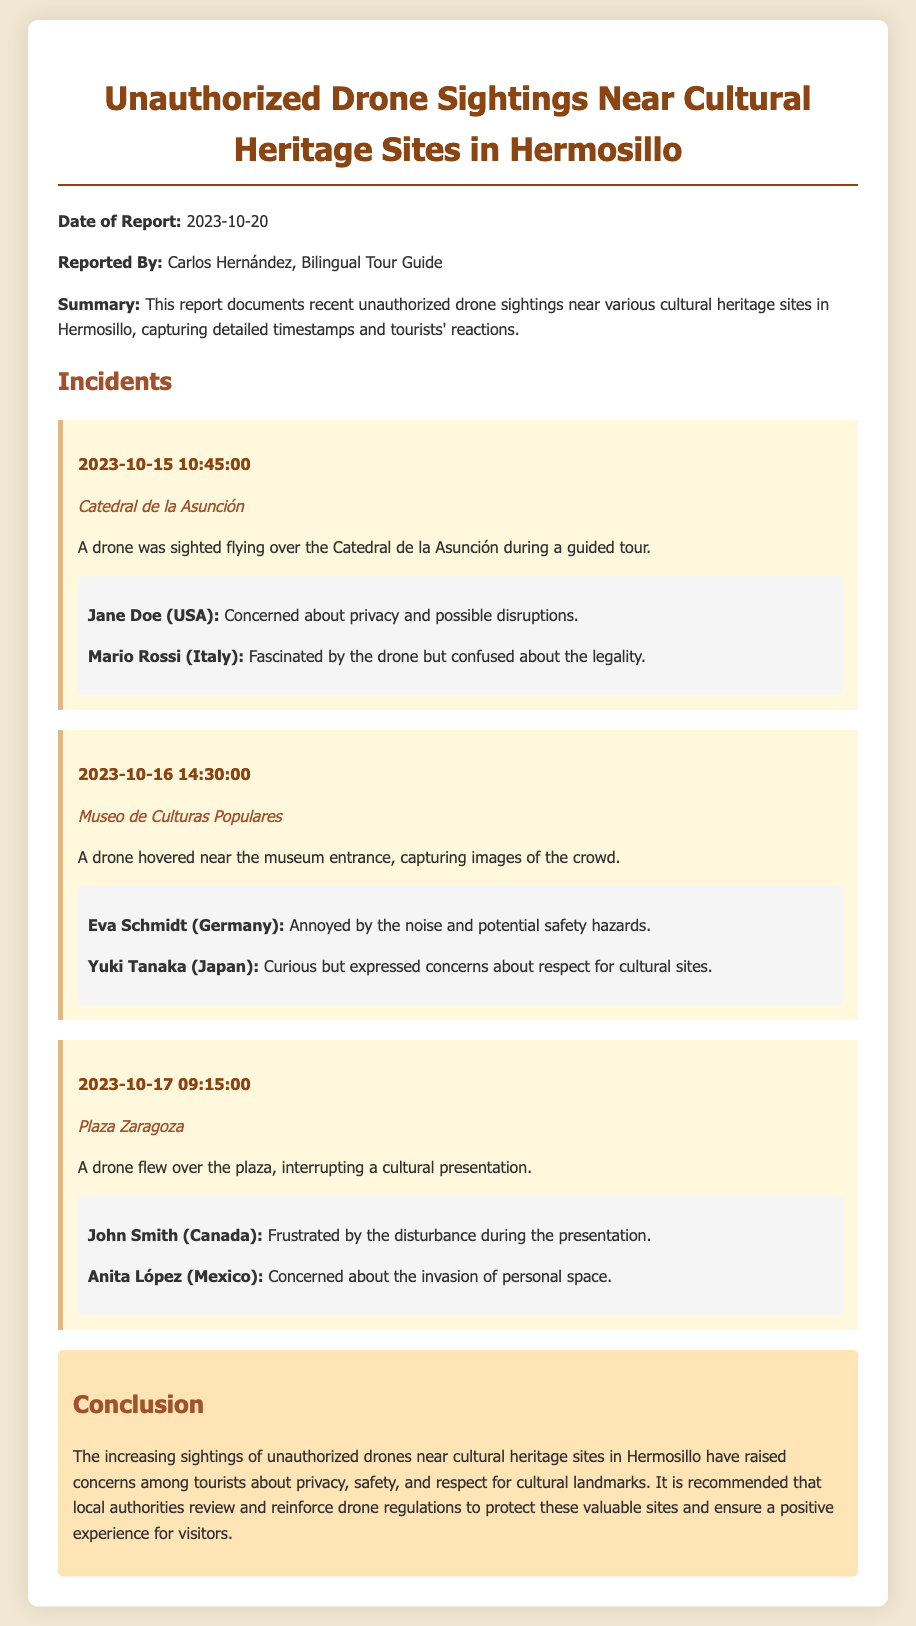What is the date of the report? The date of the report is explicitly stated at the beginning of the document as the date it was published.
Answer: 2023-10-20 Who reported the incidents? The report specifies the name of the person who documented the unauthorized drone sightings.
Answer: Carlos Hernández How many incidents are documented? By counting the distinct incidents mentioned in the report, we determine the total number of documented events.
Answer: 3 What was the location of the drone sighting on October 17? The timestamp and location of each incident are provided; this incident occurred at a specific place on that date.
Answer: Plaza Zaragoza What common concern did tourists express? Tourists shared various reactions, and one particular theme emerged in their comments across multiple incidents.
Answer: Privacy What was the recommendation at the conclusion? The conclusion of the report summarizes the suggested actions that could help address the concerns raised by tourists in the incidents described.
Answer: Review and reinforce drone regulations 